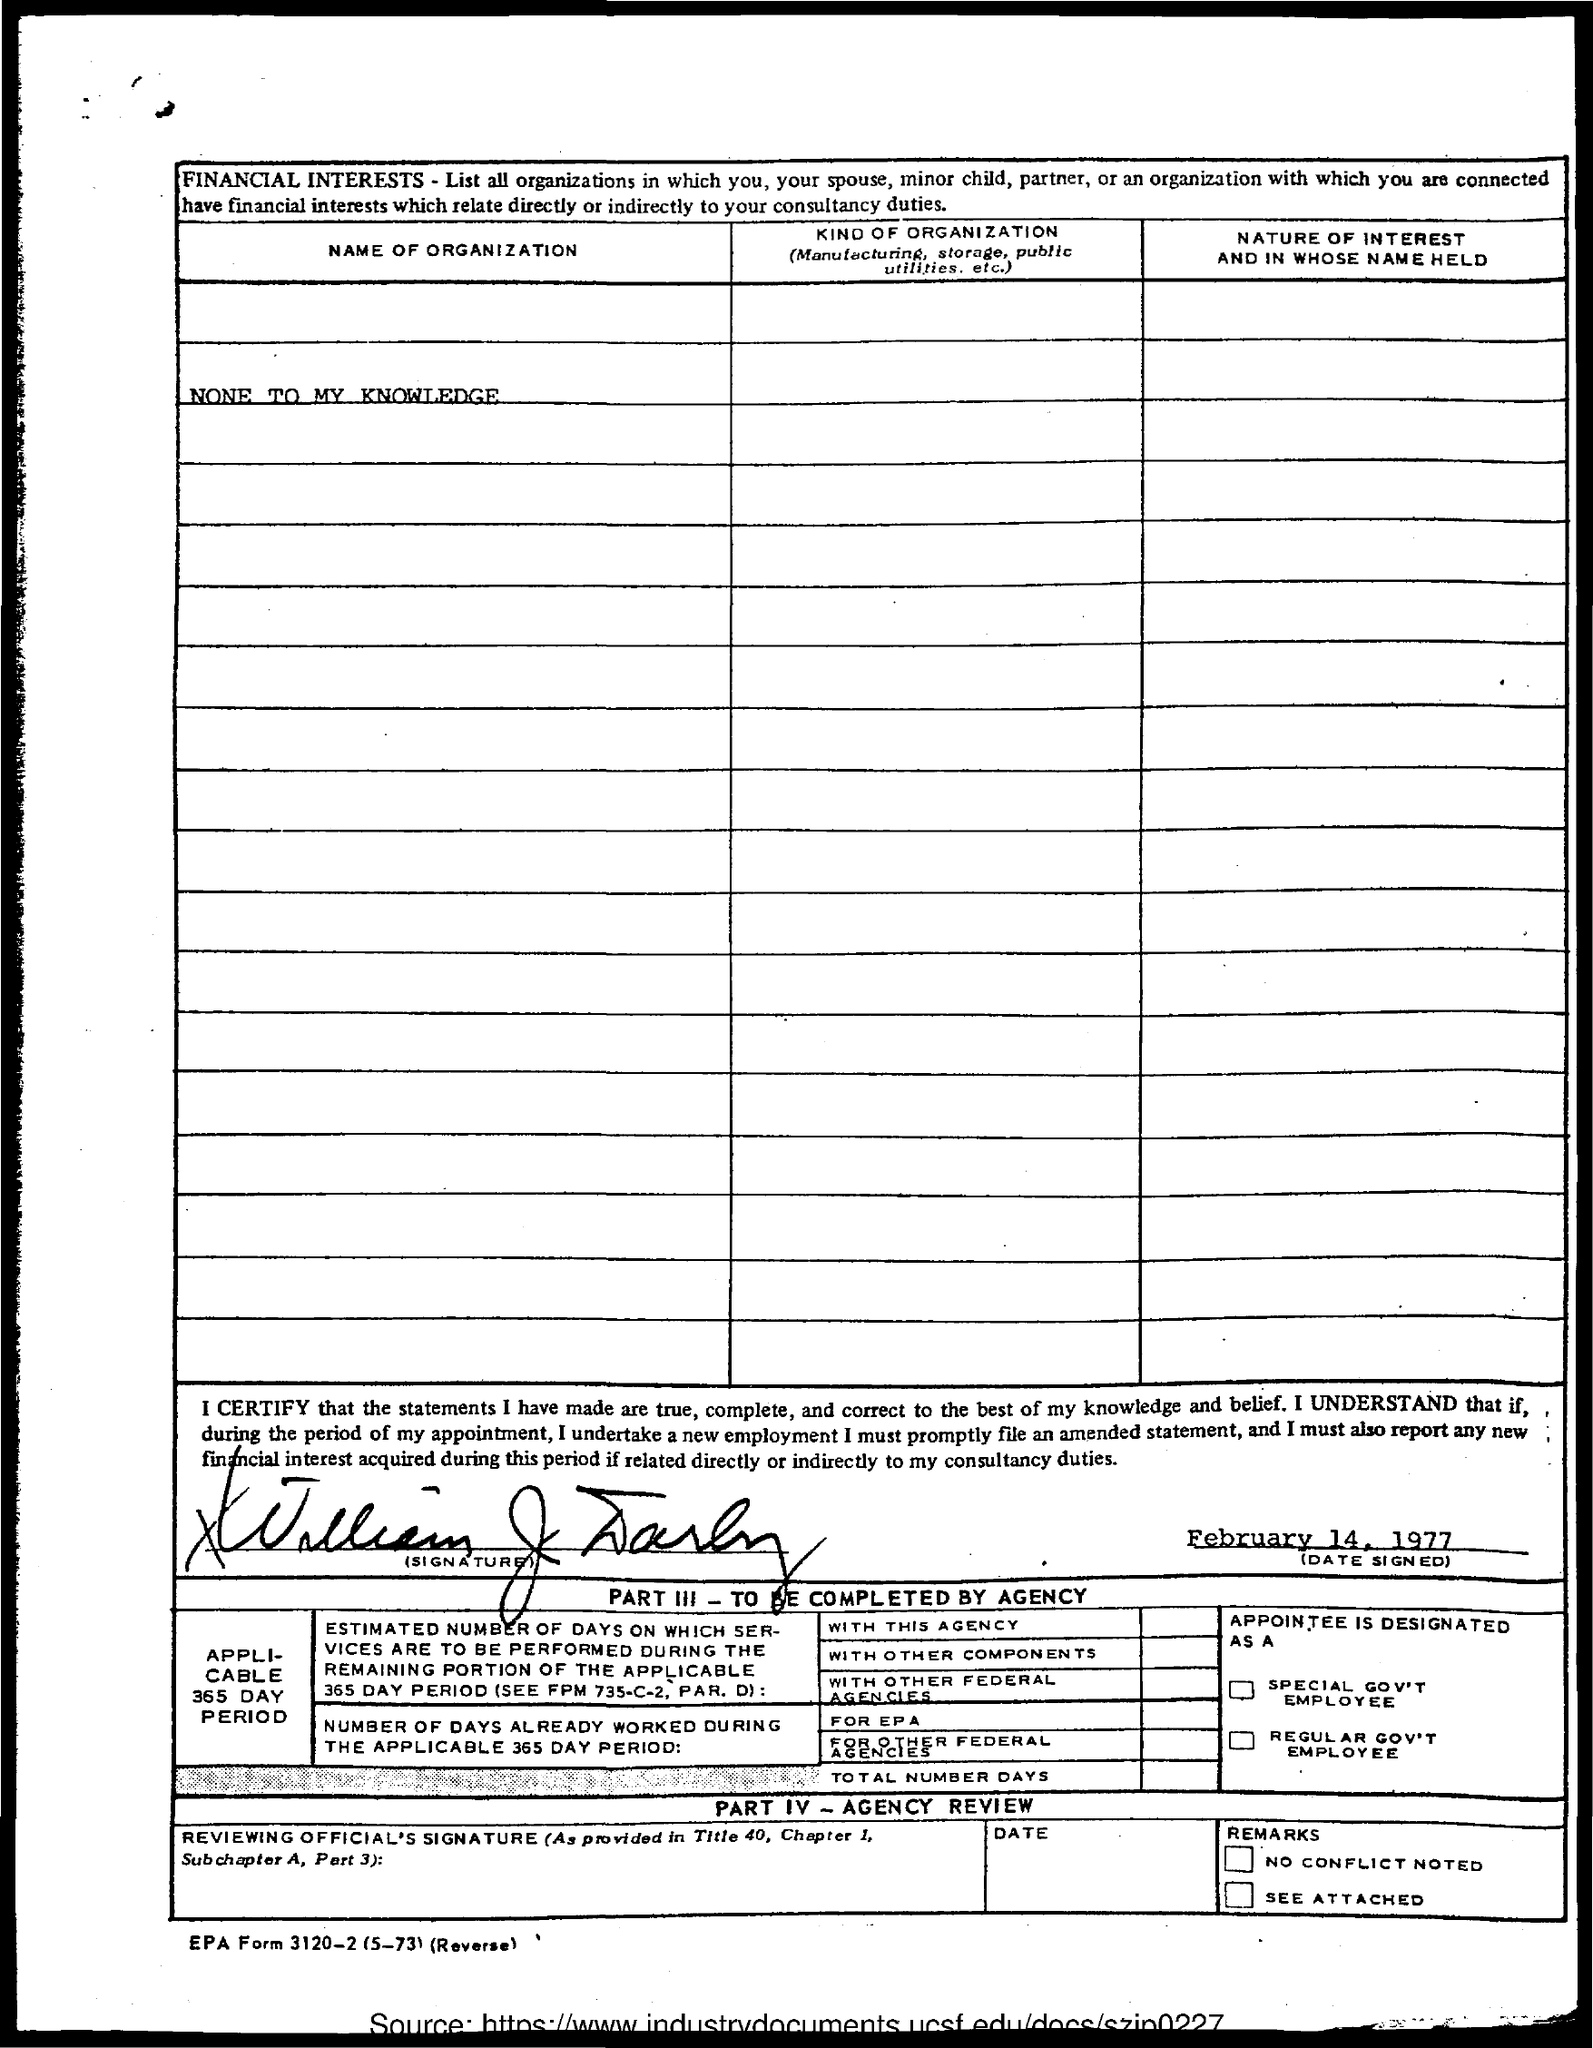Indicate a few pertinent items in this graphic. The title of the first column is 'Name of Organization'. On February 14, 1977, the signing occurred. The declaration states that the document was signed by William J. Darby. 